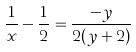Convert formula to latex. <formula><loc_0><loc_0><loc_500><loc_500>\frac { 1 } { x } - \frac { 1 } { 2 } = \frac { - y } { 2 ( y + 2 ) }</formula> 